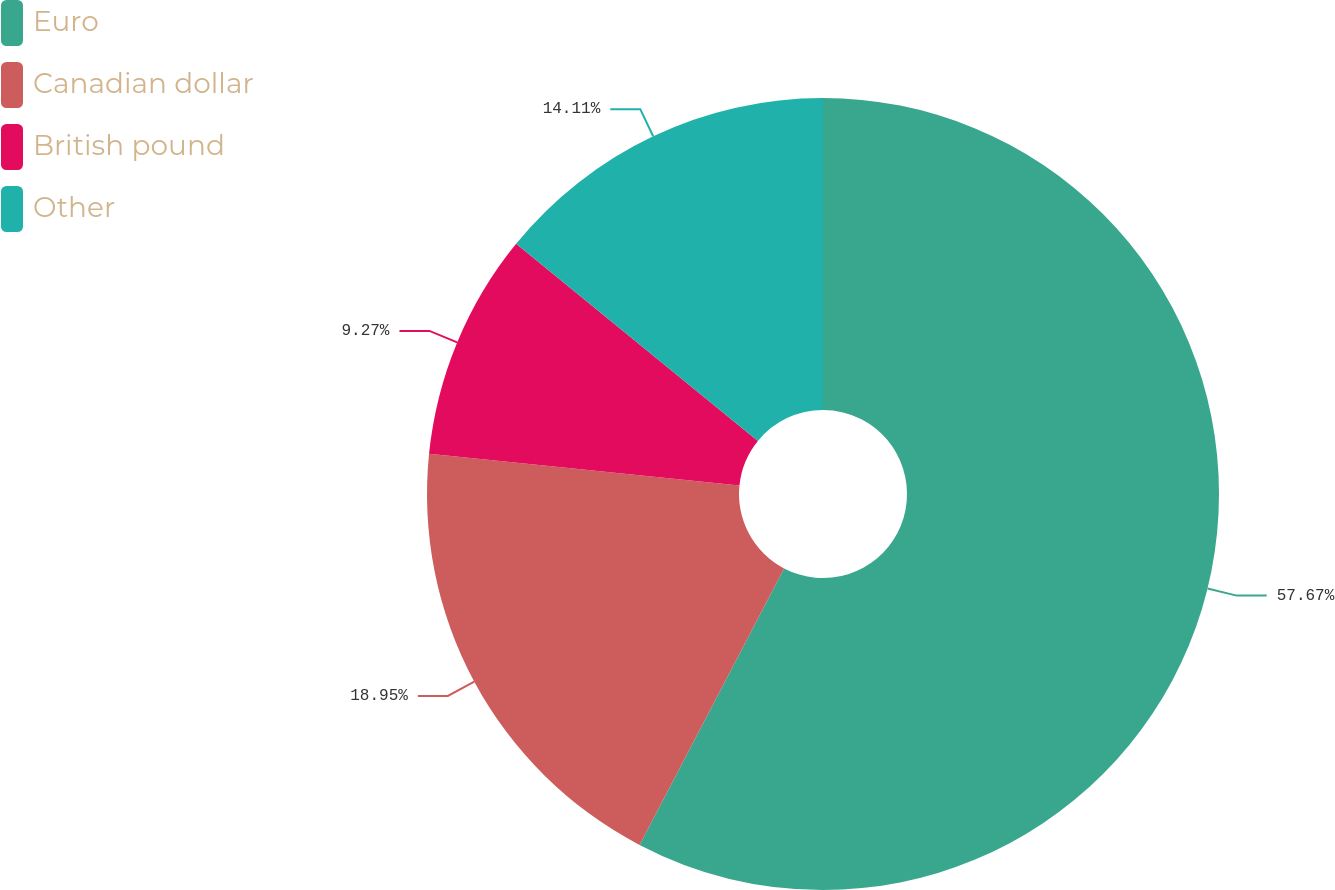Convert chart to OTSL. <chart><loc_0><loc_0><loc_500><loc_500><pie_chart><fcel>Euro<fcel>Canadian dollar<fcel>British pound<fcel>Other<nl><fcel>57.66%<fcel>18.95%<fcel>9.27%<fcel>14.11%<nl></chart> 